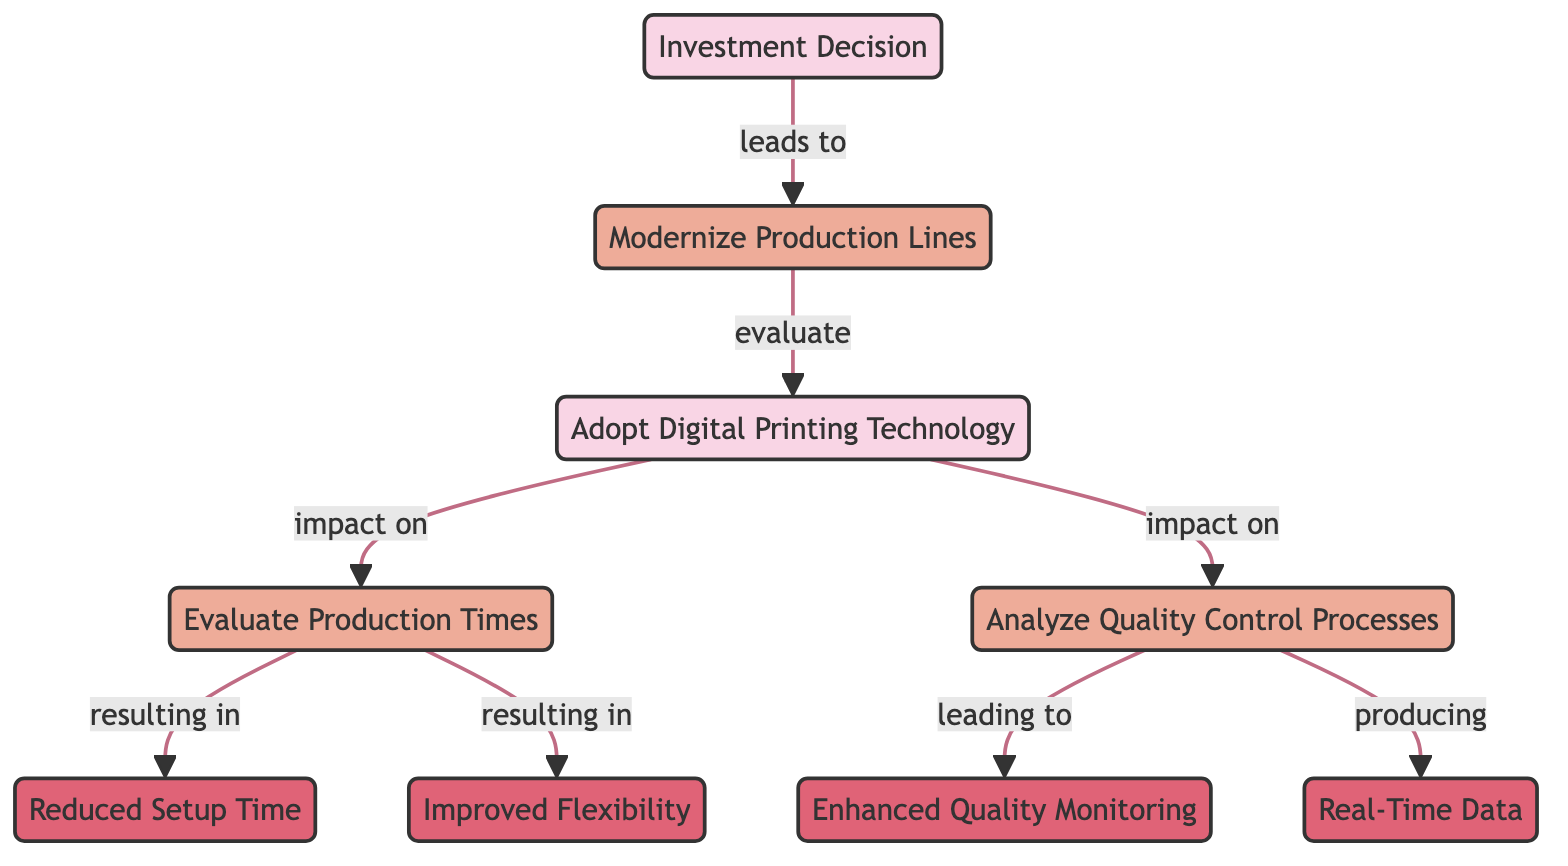What is the first step leading to production changes? The first step in the diagram is "Investment Decision," which leads directly to the next process of "Modernize Production Lines."
Answer: Investment Decision How many nodes are in the diagram? The diagram consists of 9 distinct nodes which include decisions, processes, and outcomes.
Answer: 9 What is the relationship between "Adopt Digital Printing Technology" and "Evaluate Production Times"? "Adopt Digital Printing Technology" has a direct impact on "Evaluate Production Times," as indicated by the arrow pointing from the former to the latter in the diagram.
Answer: impact on What outcomes are associated with evaluating production times? Evaluating production times results in two outcomes: "Reduced Setup Time" and "Improved Flexibility," which are directly connected to the "Evaluate Production Times" process.
Answer: Reduced Setup Time, Improved Flexibility How does analyzing quality control processes affect production outcomes? Analyzing quality control processes leads to enhanced outcomes, specifically "Enhanced Quality Monitoring" and "Real-Time Data," showing the result of careful quality analysis.
Answer: Enhanced Quality Monitoring, Real-Time Data What is the final outcome resulting from analyzing quality control processes? The final outcome produced from analyzing quality control processes in the diagram is "Real-Time Data," indicated by a direct connection from "Analyze Quality Control Processes."
Answer: Real-Time Data Which processes are evaluated after modernizing production lines? After modernizing production lines, two processes are evaluated: "Evaluate Production Times" and "Analyze Quality Control Processes," connected to the decision to adopt digital printing technology.
Answer: Evaluate Production Times, Analyze Quality Control Processes 